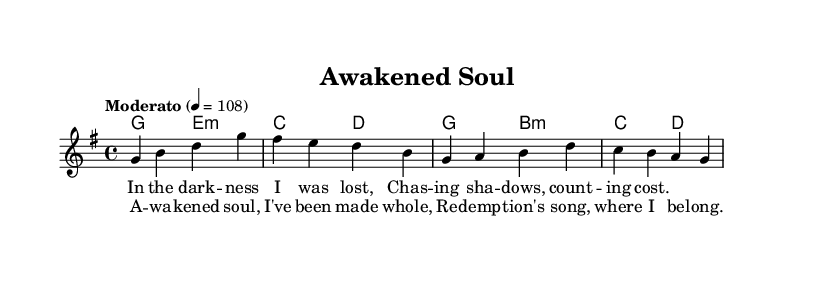What is the key signature of this music? The key signature is defined at the beginning of the sheet music, where G major is indicated. G major has one sharp (F#).
Answer: G major What is the time signature of the piece? The time signature is presented next to the key signature, which indicates how many beats are in a measure. Here, 4/4 means there are four beats per measure.
Answer: 4/4 What is the tempo marking for this piece? The tempo marking is shown in the score and indicates the speed. "Moderato" suggests a moderate pace, and the number "4 = 108" specifies the tempo as 108 beats per minute.
Answer: Moderato How many measures are in the verse and chorus combined? The verse contains 4 measures with 4 lines of lyrics, and the chorus also contains 4 measures with 2 lines of lyrics. Adding them gives a total of 8 measures.
Answer: 8 measures What is the emotional theme represented in the lyrics of the chorus? The lyrics suggest themes of spiritual transformation and belonging. Phrases like "Awakened soul" and "redemption's song" indicate a release from past struggles and a renewed sense of purpose in faith.
Answer: Redemption and belonging Which chord follows the key signature and sets the harmonic foundation? The first chord in the harmonies section is G major. This establishes the base key and supports the melody throughout the piece.
Answer: G major What message is conveyed through the overall structure of the sheet music? The structure, with verses leading to a strong chorus, represents a journey from struggle to awakening, embodying themes of hope and revival which are central to modern gospel music.
Answer: Spiritual awakening 